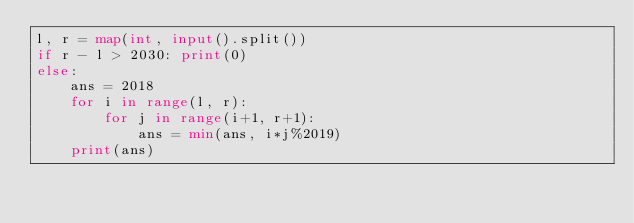<code> <loc_0><loc_0><loc_500><loc_500><_Python_>l, r = map(int, input().split())
if r - l > 2030: print(0)
else:
    ans = 2018
    for i in range(l, r):
        for j in range(i+1, r+1):
            ans = min(ans, i*j%2019)
    print(ans)</code> 